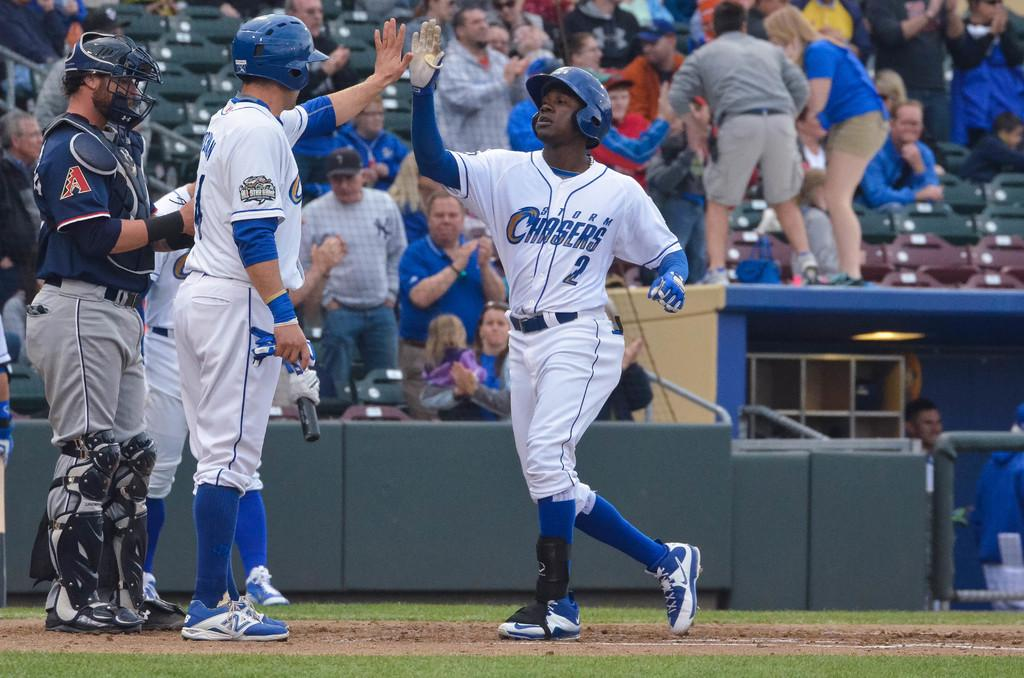Provide a one-sentence caption for the provided image. Number 2 for the Storm Chasers just scored a run for his team. 